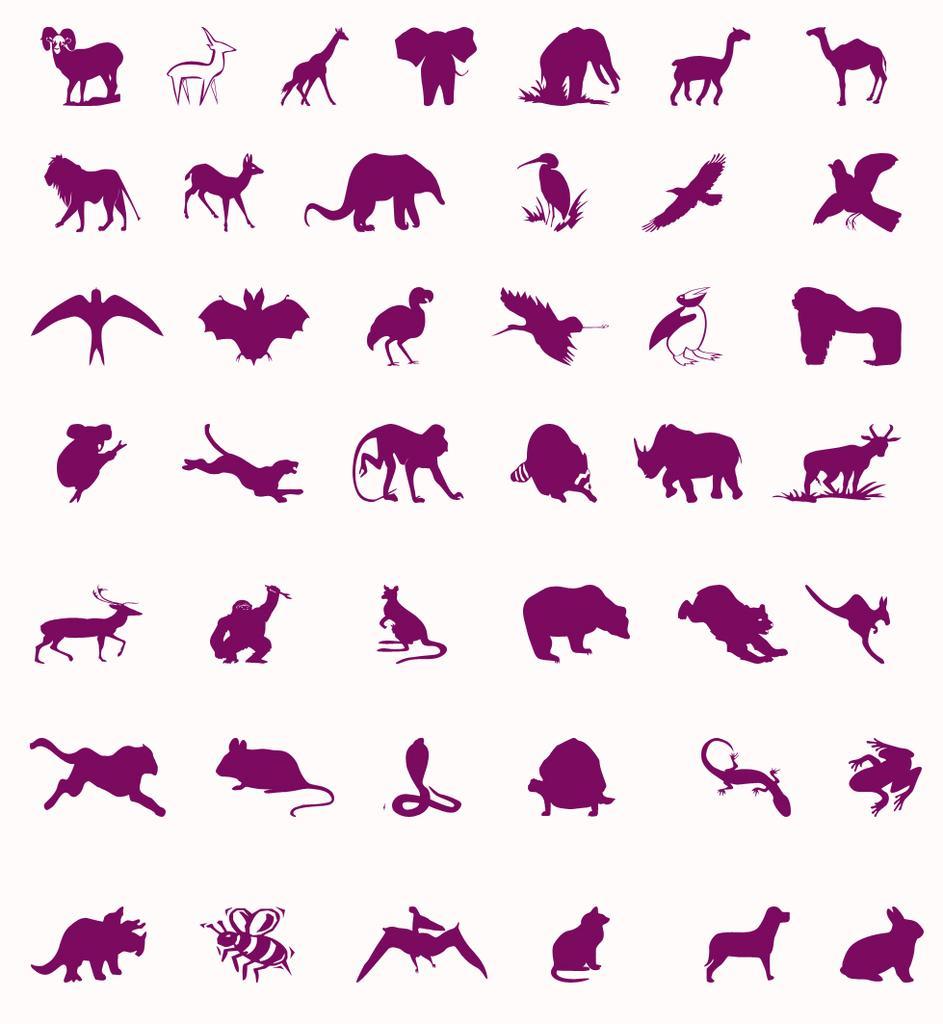How would you summarize this image in a sentence or two? In this image there are different kinds of birds and animals. 